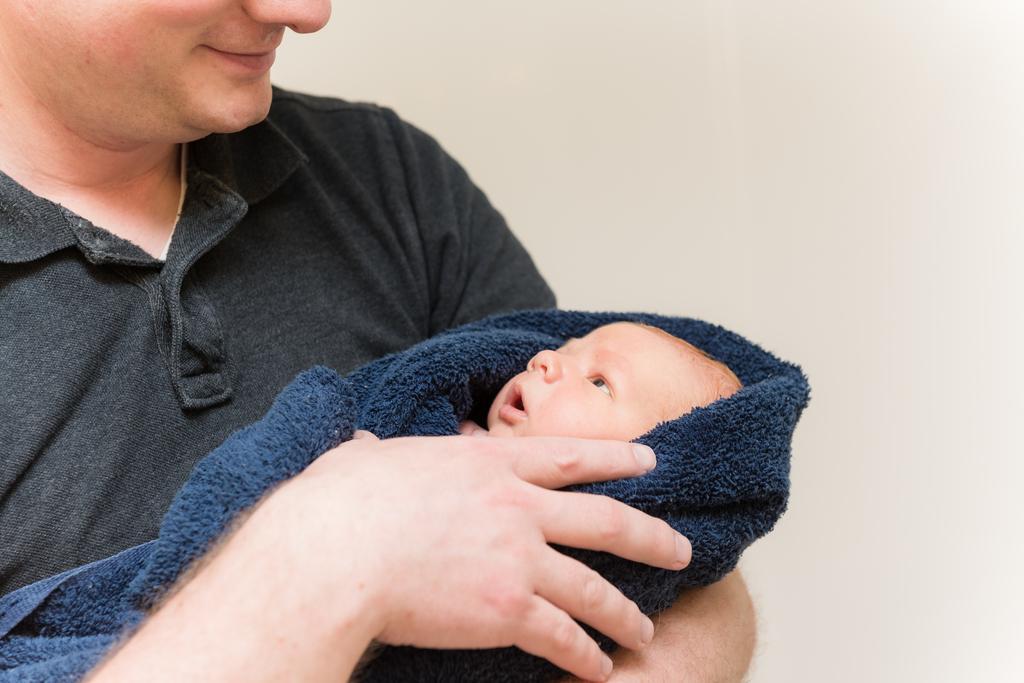Could you give a brief overview of what you see in this image? In this image, we can see a person holding a baby with cloth and in the background, there is a wall. 